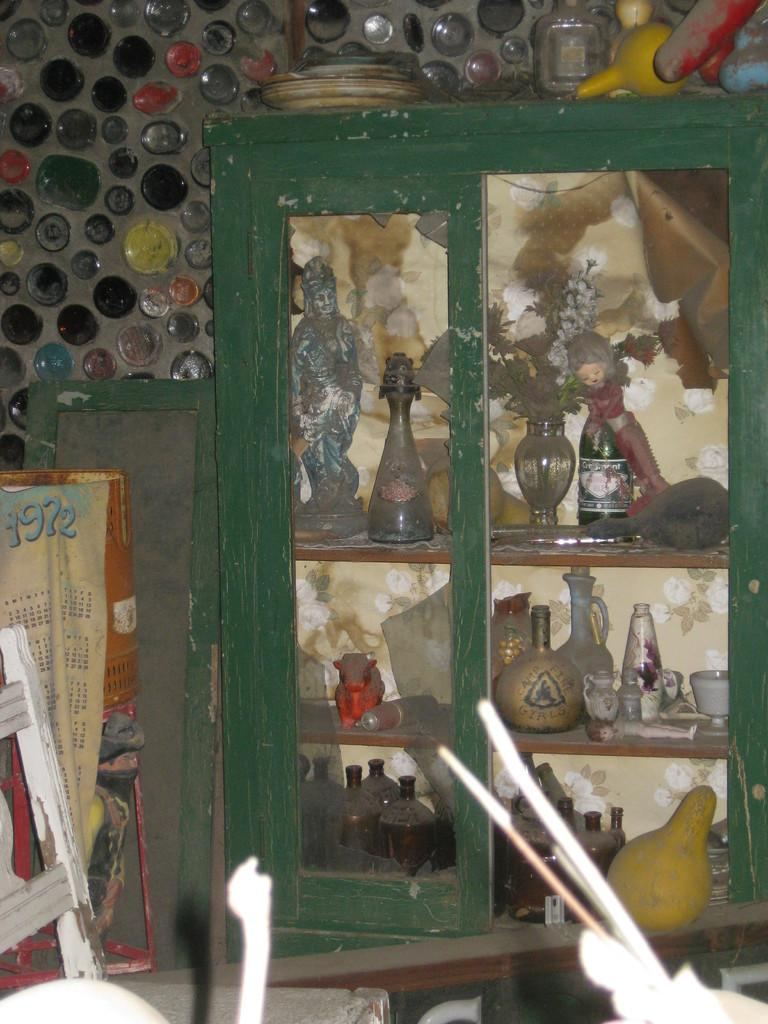What type of containers can be seen in the image? There are many jars and jugs in the image. What other object is present in the image? There is a flower vase in the image. Where are the jars, jugs, and flower vase located? They are in a cupboard. What can be seen above the cupboard? There are many jars and plates above the cupboard. What material is the back wall made of? The back wall is made of glass. What is visible in the front of the image? There is furniture in the front of the image. Can you see any caves in the image? No, there are no caves present in the image. How does the flower vase look in the image? The question is a bit unclear, but the image only provides visual information, not descriptions of how objects look. The flower vase is simply visible in the image. 